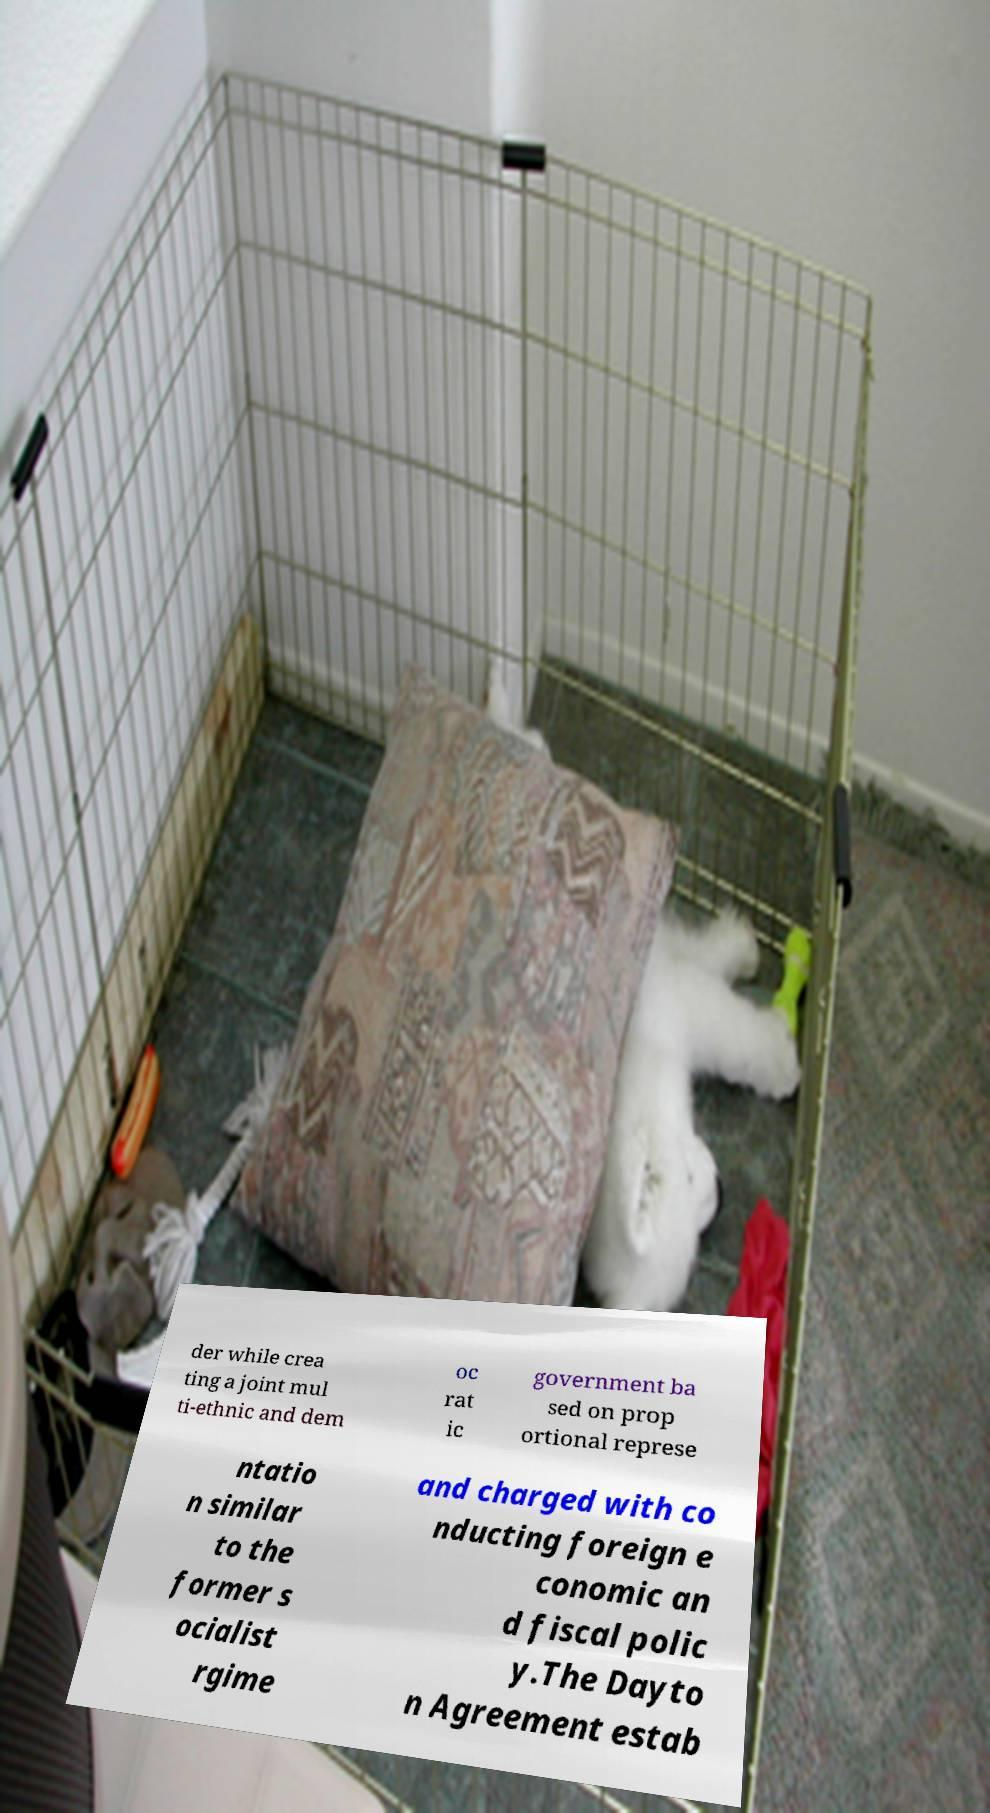What messages or text are displayed in this image? I need them in a readable, typed format. der while crea ting a joint mul ti-ethnic and dem oc rat ic government ba sed on prop ortional represe ntatio n similar to the former s ocialist rgime and charged with co nducting foreign e conomic an d fiscal polic y.The Dayto n Agreement estab 